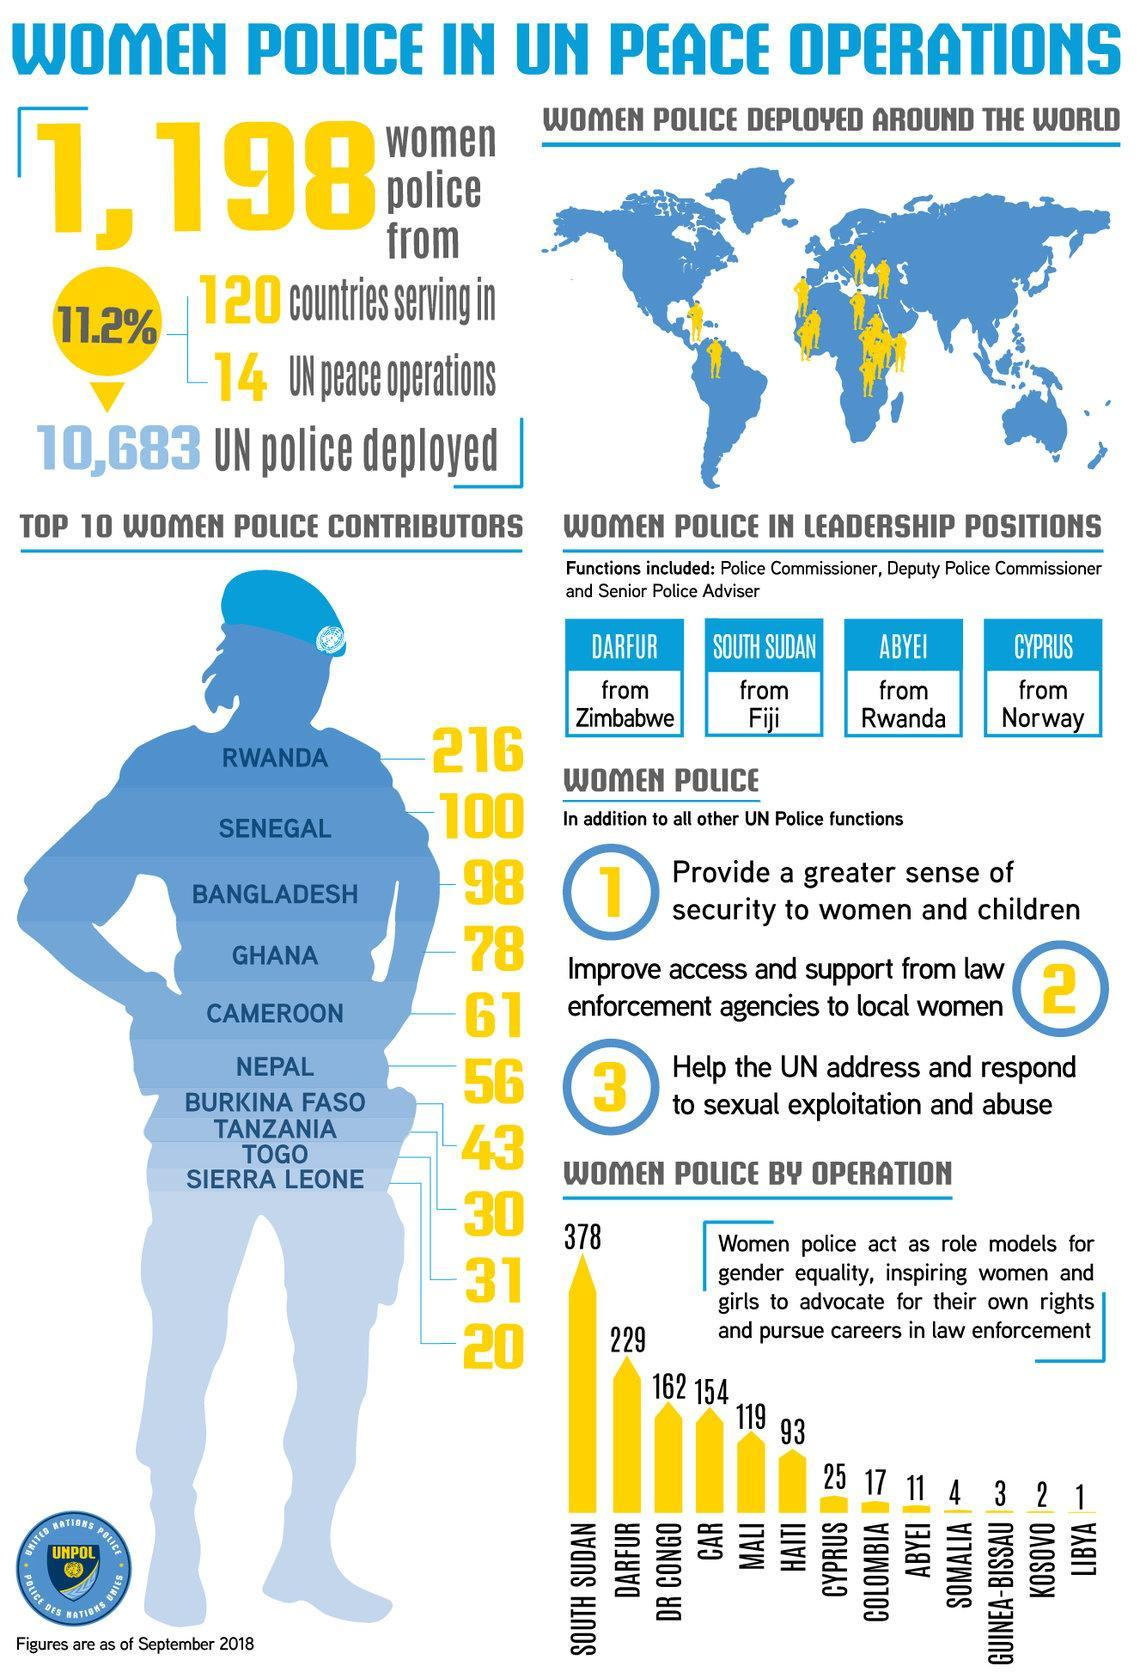Which country has the second most number of women police by operation?
Answer the question with a short phrase. Darfur How many women police are contributed by Rwanda and Senegal? 316 How many women police are contributed by Ghana and Cameroon? 139 Which country comes in 5th in top 10 women police contributors? Cameroon How many women police are contributed by Bangladesh and Nepal? 154 Which country comes in ninth in top 10 women police contributors? Togo Which country comes in sixth in top 10 women police contributors? Nepal How many women police are contributed by Togo and sierra leone? 51 Which country comes in second in top 10 women police contributors? Senegal Which country has the fifth most number of women police by operation? Mali 